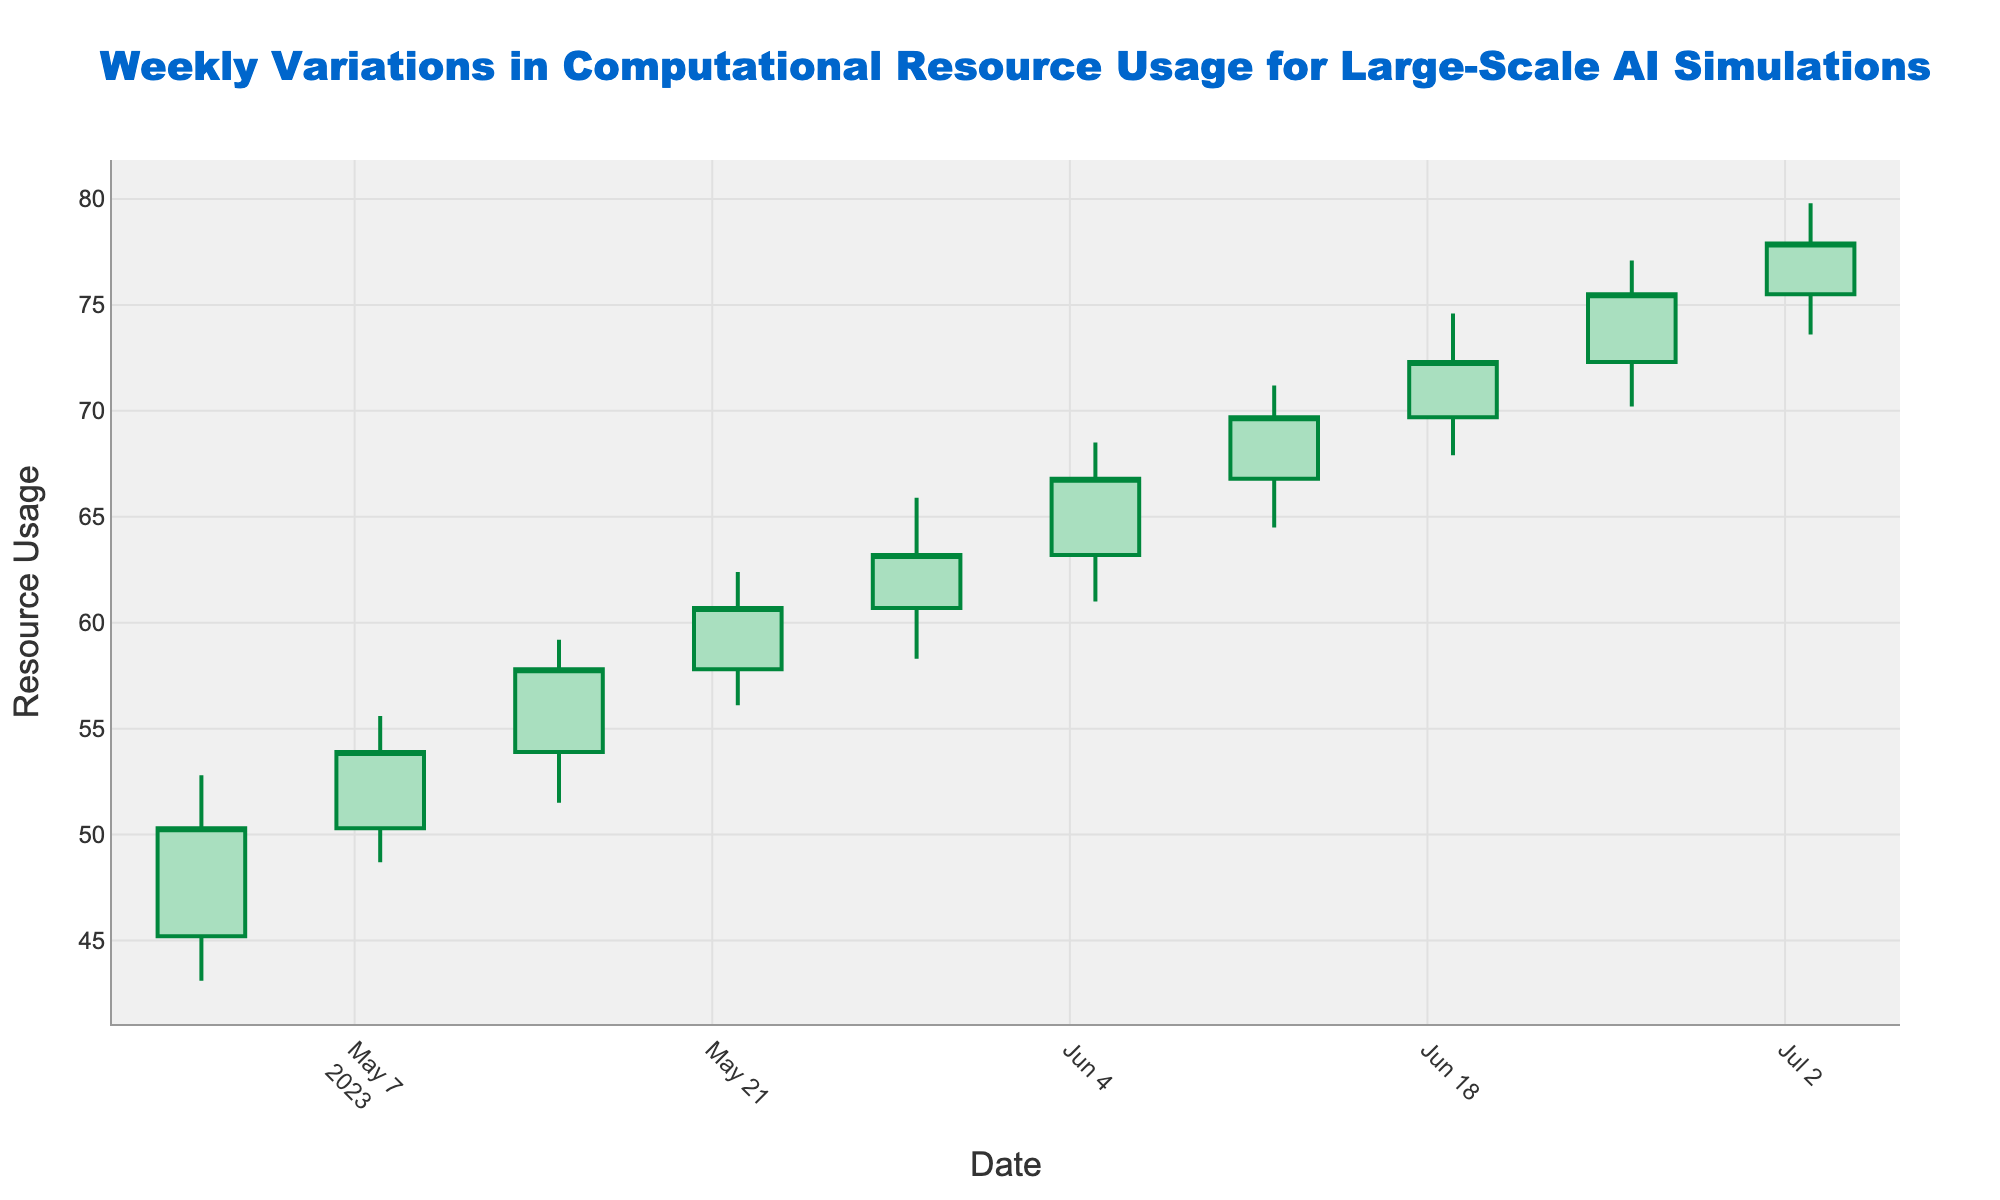What is the title of the chart? The title is typically displayed at the top of the chart. In this case, it states the main purpose of the visualization.
Answer: Weekly Variations in Computational Resource Usage for Large-Scale AI Simulations What does the y-axis represent? The y-axis label is found on the left side of the chart and indicates what is being measured.
Answer: Resource Usage How does the color of increasing and decreasing lines differ? The chart uses different colors to distinguish between increasing and decreasing trends. Increasing trends are shown in one color, and decreasing trends in another.
Answer: Increasing lines are green, and decreasing lines are red Which week had the highest high value and what was it? By looking at the highest points on the candlestick lines, you can identify the week with the highest high value.
Answer: The week of June 26; 77.1 How many data points are there in the chart? The number of data points is identical to the number of candlesticks shown, each representing a week.
Answer: 10 What weeks had a closing value lower than the opening value? Look for weeks where the closing value is lower than the opening value, indicated by red candlesticks.
Answer: None What is the average closing value over the 10 weeks? Add all the closing values together and divide by 10 to get the average closing value.
Answer: (50.3 + 53.9 + 57.8 + 60.7 + 63.2 + 66.8 + 69.7 + 72.3 + 75.5 + 77.9) / 10 = 64.81 Did the resource usage trend generally increase or decrease from May to July? Observe the overall movement of the closing values from May to July by following the candlesticks' direction.
Answer: Increased What was the week with the smallest range between the high and low values, and what was that range? Calculate the range for each week by subtracting the low value from the high value, and compare them.
Answer: May 01; 9.7 During which weeks did the closing value consistently increase? Check for consecutive weeks where each week's closing value is higher than the previous week's.
Answer: Every week from May 1 to July 3 